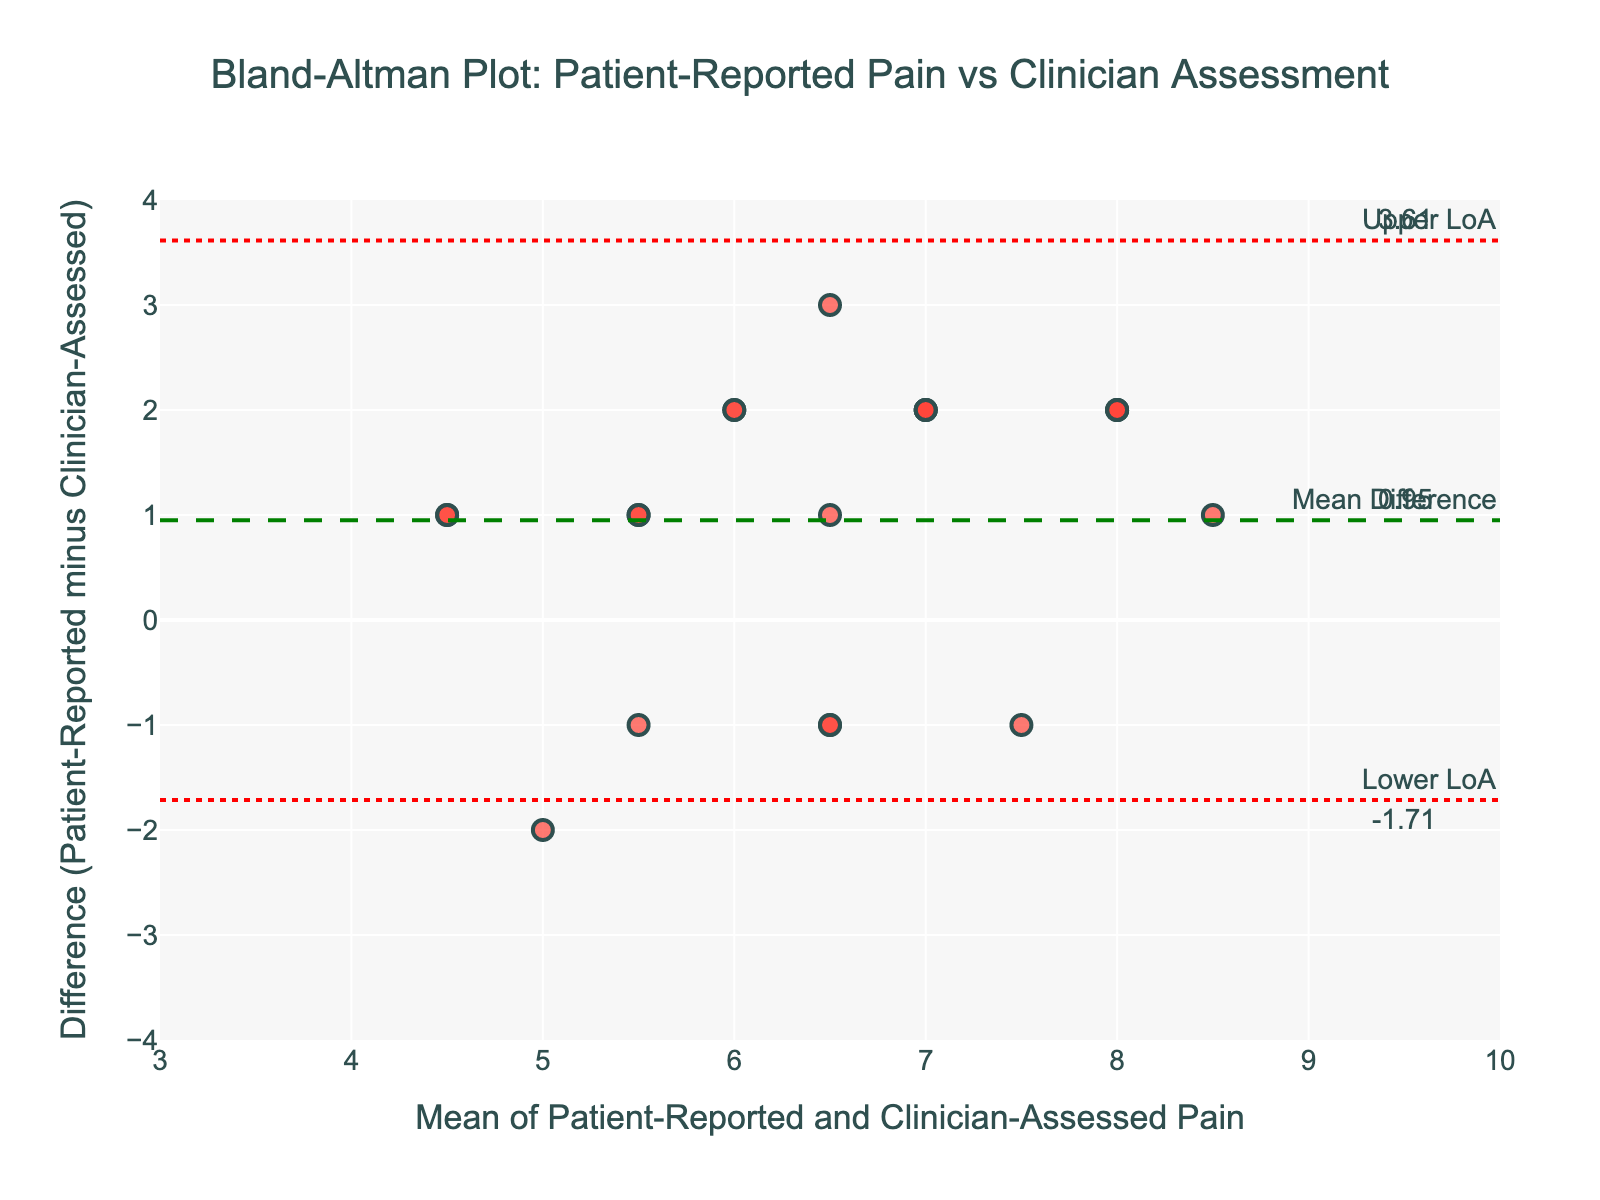What is the title of the plot? The title of the plot is displayed at the top of the figure and usually summarizes what the plot depicts. In this case, it indicates the comparison being made.
Answer: Bland-Altman Plot: Patient-Reported Pain vs Clinician Assessment What does the y-axis represent? The y-axis label provides the necessary information. Here, it shows the difference between patient-reported and clinician-assessed pain levels.
Answer: Difference (Patient-Reported minus Clinician-Assessed) How many patients' data points are displayed in the plot? By counting the number of markers (data points) on the plot, you can determine the number of patients included.
Answer: 20 What is the mean difference between patient-reported and clinician-assessed pain levels? A horizontal dashed line is drawn at the mean difference value, which is also annotated on the right-hand side of the plot.
Answer: 0.10 What is the range of the x-axis? The range of the x-axis can be determined by looking at the minimum and maximum values shown on the axis scale. In this plot, the range goes from 3 to 10.
Answer: 3 to 10 What is the upper limit of agreement (LoA) value? The upper limit of agreement is shown with a dotted red line and annotated value towards the right-hand side of the plot.
Answer: 3.00 What is the mean of patient-reported and clinician-assessed pain levels for Sarah Davis? To find this, first locate Sarah Davis's data (patient-reported pain level of 9 and clinician-assessed level of 7), then calculate the average: (9+7)/2.
Answer: 8 What is the difference between the patient-reported and clinician-assessed pain levels for Michael Brown? Michael Brown's data shows patient-reported pain level of 6 and clinician-assessed level of 7. The difference is 6 - 7.
Answer: -1 Which data point shows the highest positive difference? The patient with the largest positive value on the y-axis indicates the greatest positive difference. Here, Daniel Harris's difference (patient-reported 8 and clinician-assessed 5) of 3 is the highest.
Answer: Daniel Harris What is the range for the differences between patient-reported and clinician-assessed pain levels? By looking at the y-axis, you can see the minimum and maximum values for the differences, which are from -2 to 3.
Answer: -2 to 3 